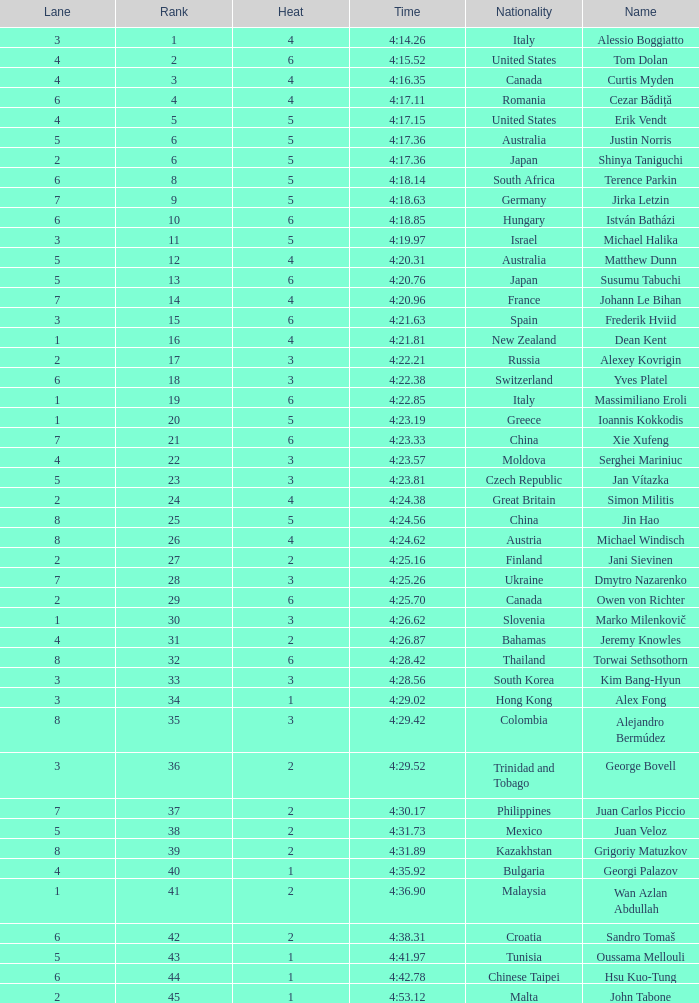Who was the 4 lane person from Canada? 4.0. 